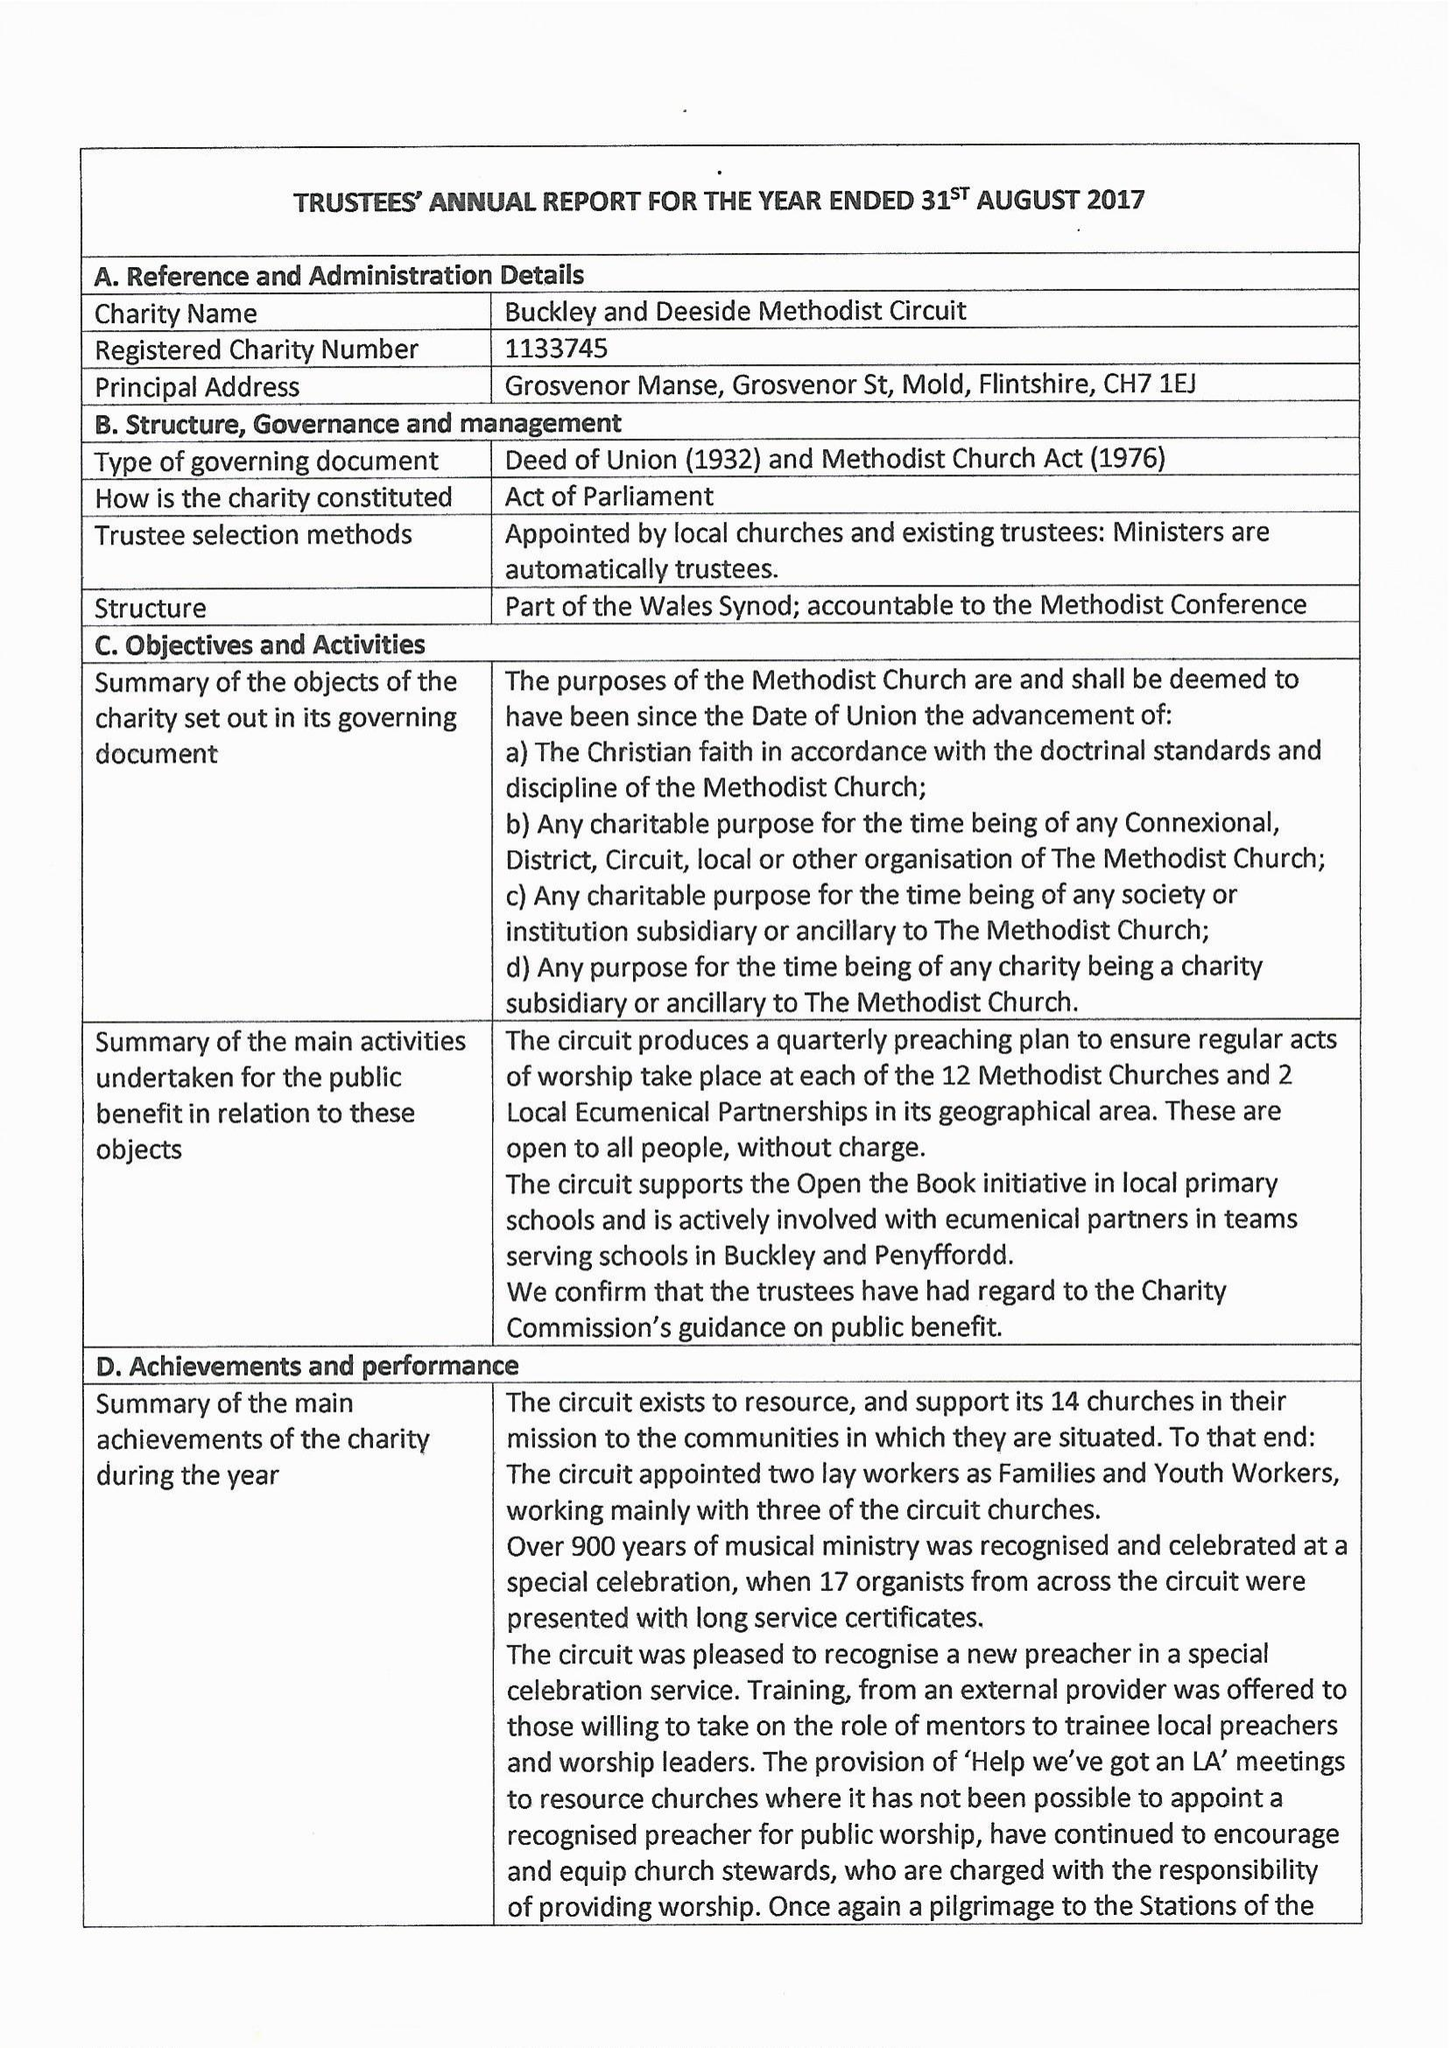What is the value for the charity_number?
Answer the question using a single word or phrase. 1133745 